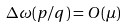<formula> <loc_0><loc_0><loc_500><loc_500>\Delta \omega ( p / q ) = O ( \mu )</formula> 